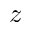Convert formula to latex. <formula><loc_0><loc_0><loc_500><loc_500>z</formula> 